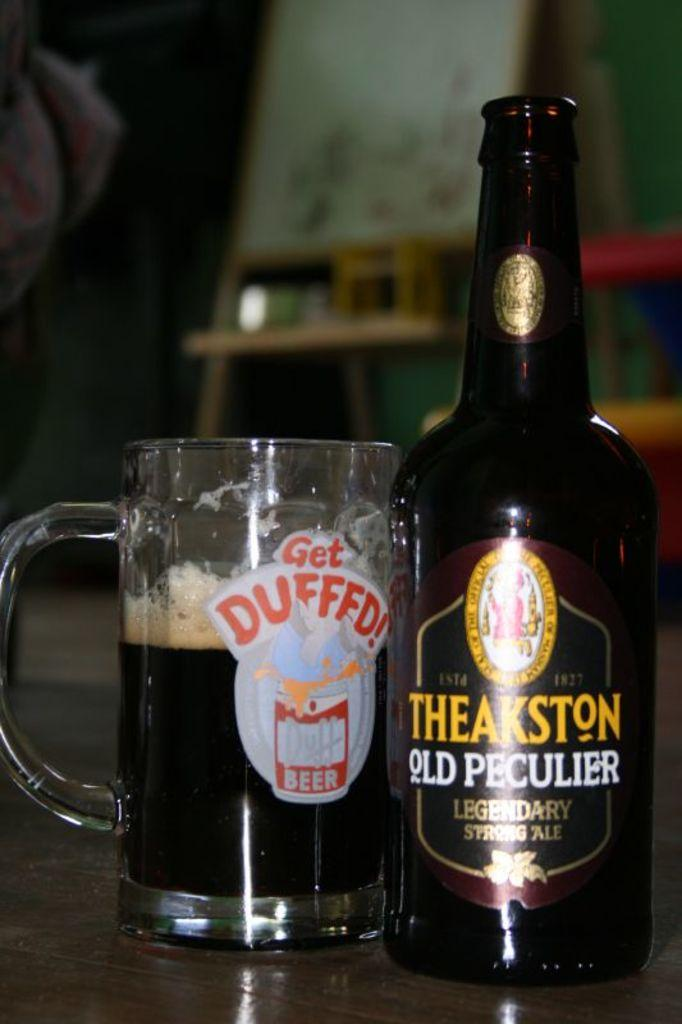<image>
Render a clear and concise summary of the photo. Bottle of Theakston Old Peculier next to a cup of Get Duffed beer. 